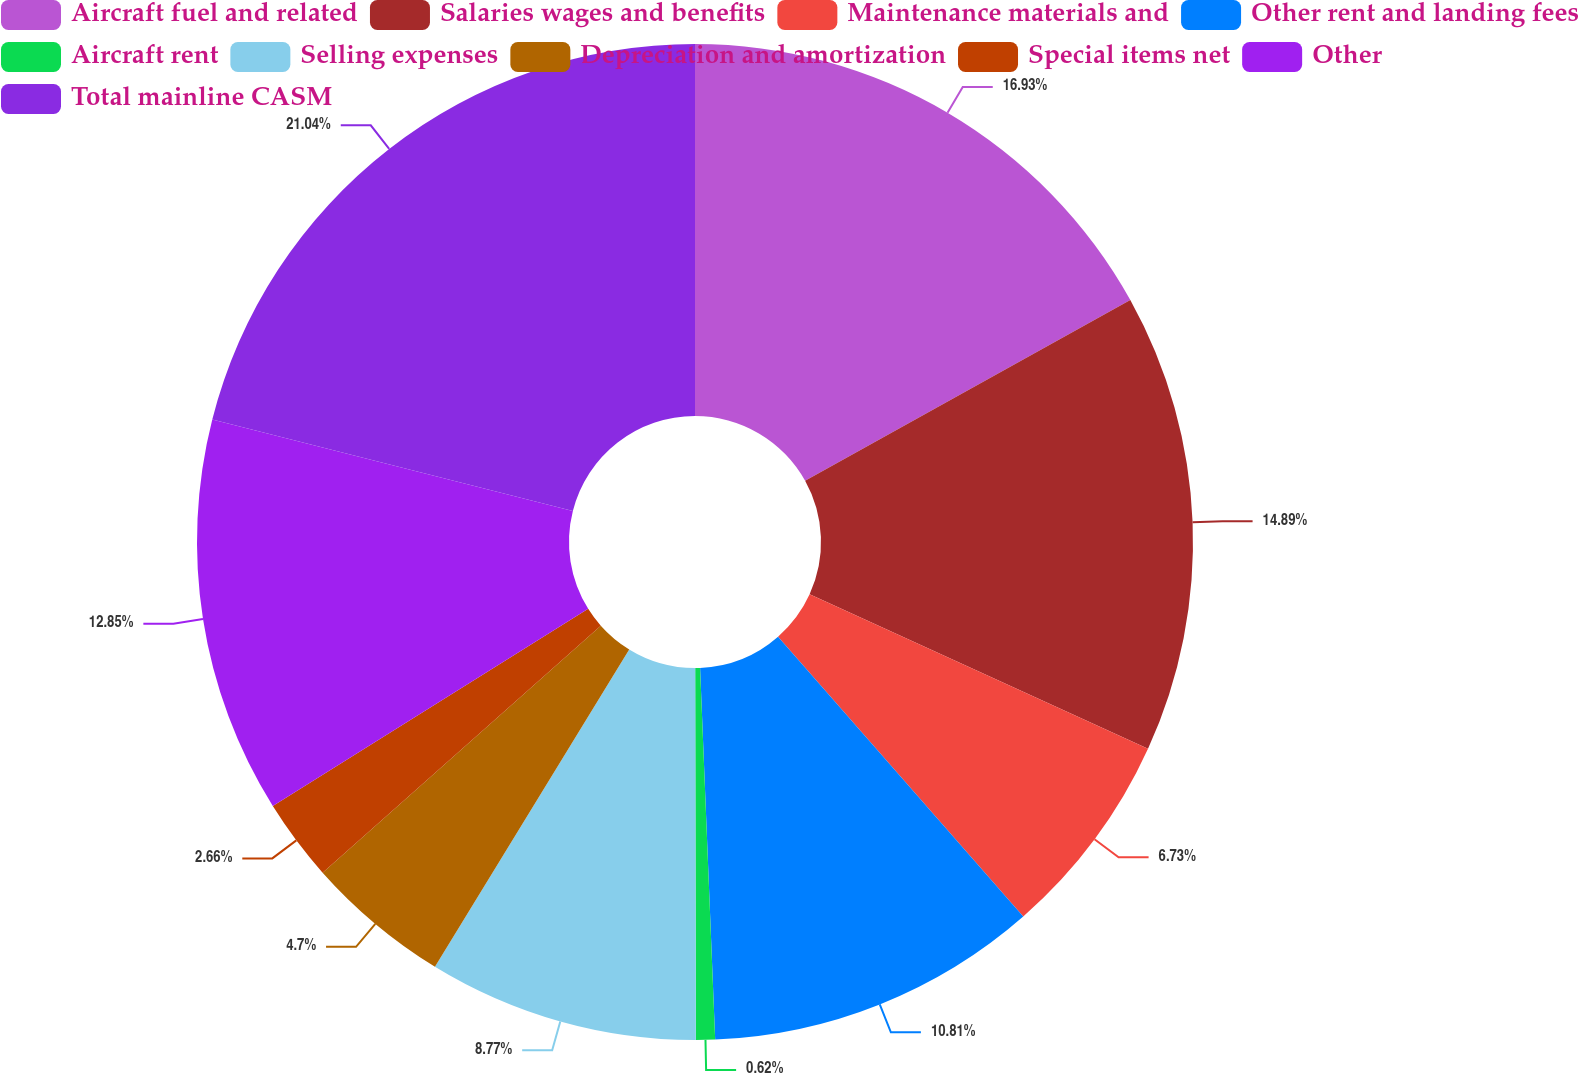Convert chart. <chart><loc_0><loc_0><loc_500><loc_500><pie_chart><fcel>Aircraft fuel and related<fcel>Salaries wages and benefits<fcel>Maintenance materials and<fcel>Other rent and landing fees<fcel>Aircraft rent<fcel>Selling expenses<fcel>Depreciation and amortization<fcel>Special items net<fcel>Other<fcel>Total mainline CASM<nl><fcel>16.93%<fcel>14.89%<fcel>6.73%<fcel>10.81%<fcel>0.62%<fcel>8.77%<fcel>4.7%<fcel>2.66%<fcel>12.85%<fcel>21.05%<nl></chart> 